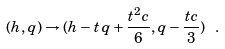Convert formula to latex. <formula><loc_0><loc_0><loc_500><loc_500>( h , q ) \rightarrow ( h - t \, q + \frac { t ^ { 2 } c } { 6 } , q - \frac { t c } { 3 } ) \ .</formula> 